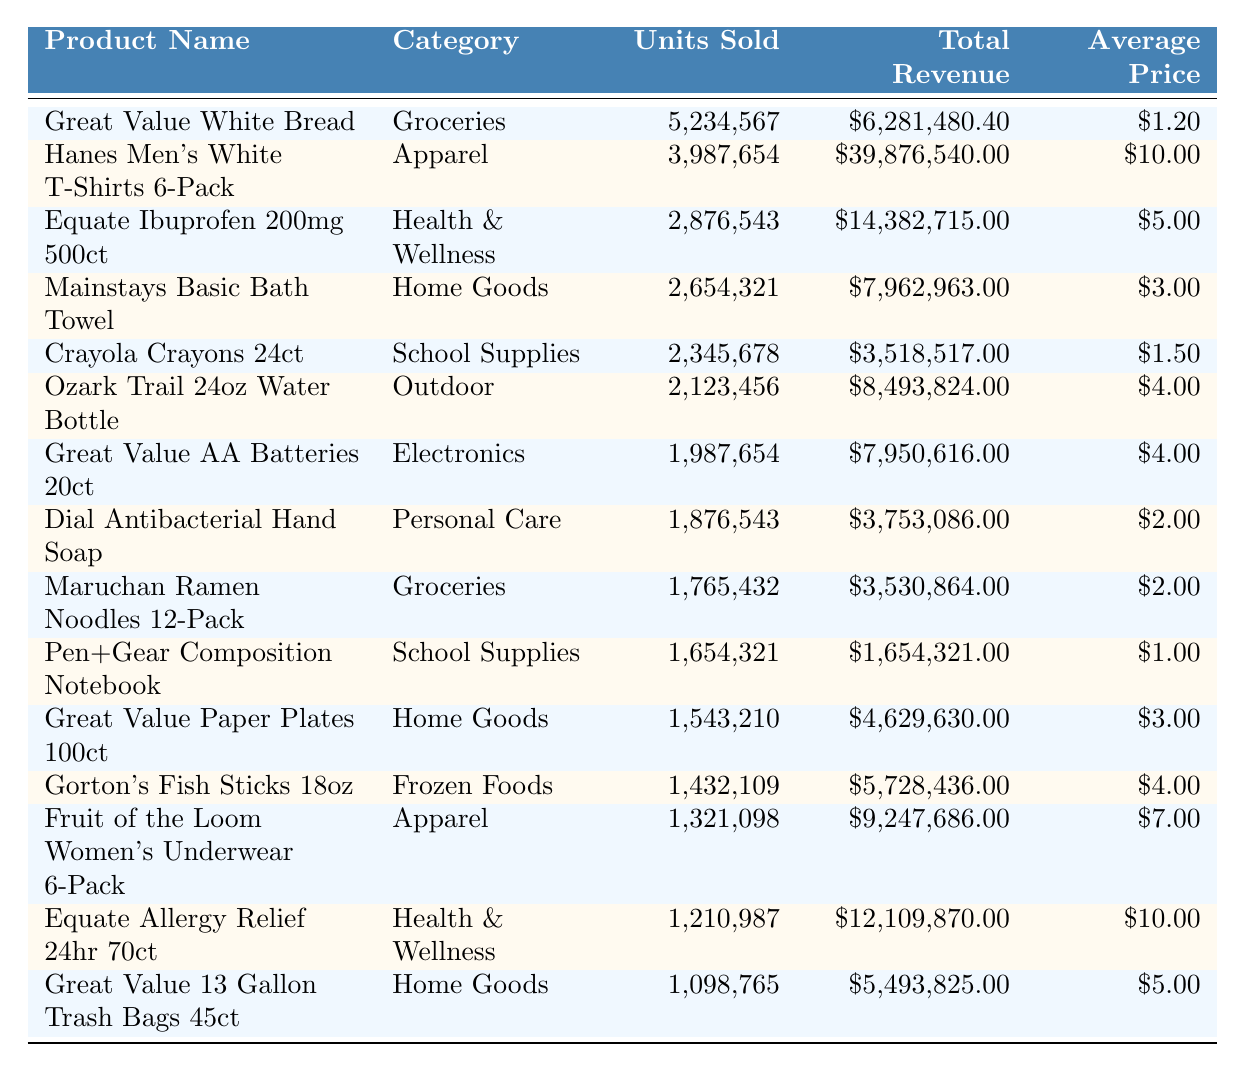What is the product with the highest units sold? By scanning the table for the "Units Sold" column, "Great Value White Bread" has the highest value of 5,234,567 units sold.
Answer: Great Value White Bread Which category has the highest total revenue? Observing the "Total Revenue" column, "Hanes Men's White T-Shirts 6-Pack" under "Apparel" has the highest total revenue at $39,876,540.00.
Answer: Apparel What is the average price of "Equate Ibuprofen 200mg 500ct"? The price is listed directly in the table, showing an average price of $5.00 for "Equate Ibuprofen 200mg 500ct".
Answer: $5.00 How many units were sold for "Maruchan Ramen Noodles 12-Pack"? The units sold are specified in the table as 1,765,432 for "Maruchan Ramen Noodles 12-Pack".
Answer: 1,765,432 What is the total revenue of the top-selling product? The top-selling product is "Great Value White Bread," which generated a total revenue of $6,281,480.40 as shown in the table.
Answer: $6,281,480.40 Which product had sales of more than 2 million units? By reviewing the "Units Sold" column, the products "Great Value White Bread," "Hanes Men's White T-Shirts 6-Pack," "Equate Ibuprofen 200mg 500ct," "Mainstays Basic Bath Towel," and "Crayola Crayons 24ct" all sold more than 2 million units.
Answer: Five products If you combine the units sold for "Great Value AA Batteries 20ct" and "Dial Antibacterial Hand Soap," how many units were sold in total? Adding the units sold from the table: 1,987,654 (Great Value AA Batteries) + 1,876,543 (Dial Antibacterial Hand Soap) totals to 3,864,197 units sold.
Answer: 3,864,197 Is the average price of "Fruit of the Loom Women's Underwear 6-Pack" more than $5.00? The average price listed for "Fruit of the Loom Women's Underwear 6-Pack" is $7.00, which is indeed more than $5.00.
Answer: Yes What product has the lowest average price, and what is that price? "Pen+Gear Composition Notebook" has the lowest average price of $1.00 according to the table.
Answer: $1.00 What is the total revenue of all products in the Home Goods category? Summing the total revenue of the Home Goods products from the table gives $7,962,963 (Mainstays Basic Bath Towel) + $4,629,630 (Great Value Paper Plates 100ct) + $5,493,825 (Great Value 13 Gallon Trash Bags 45ct) = $18,086,418.
Answer: $18,086,418 